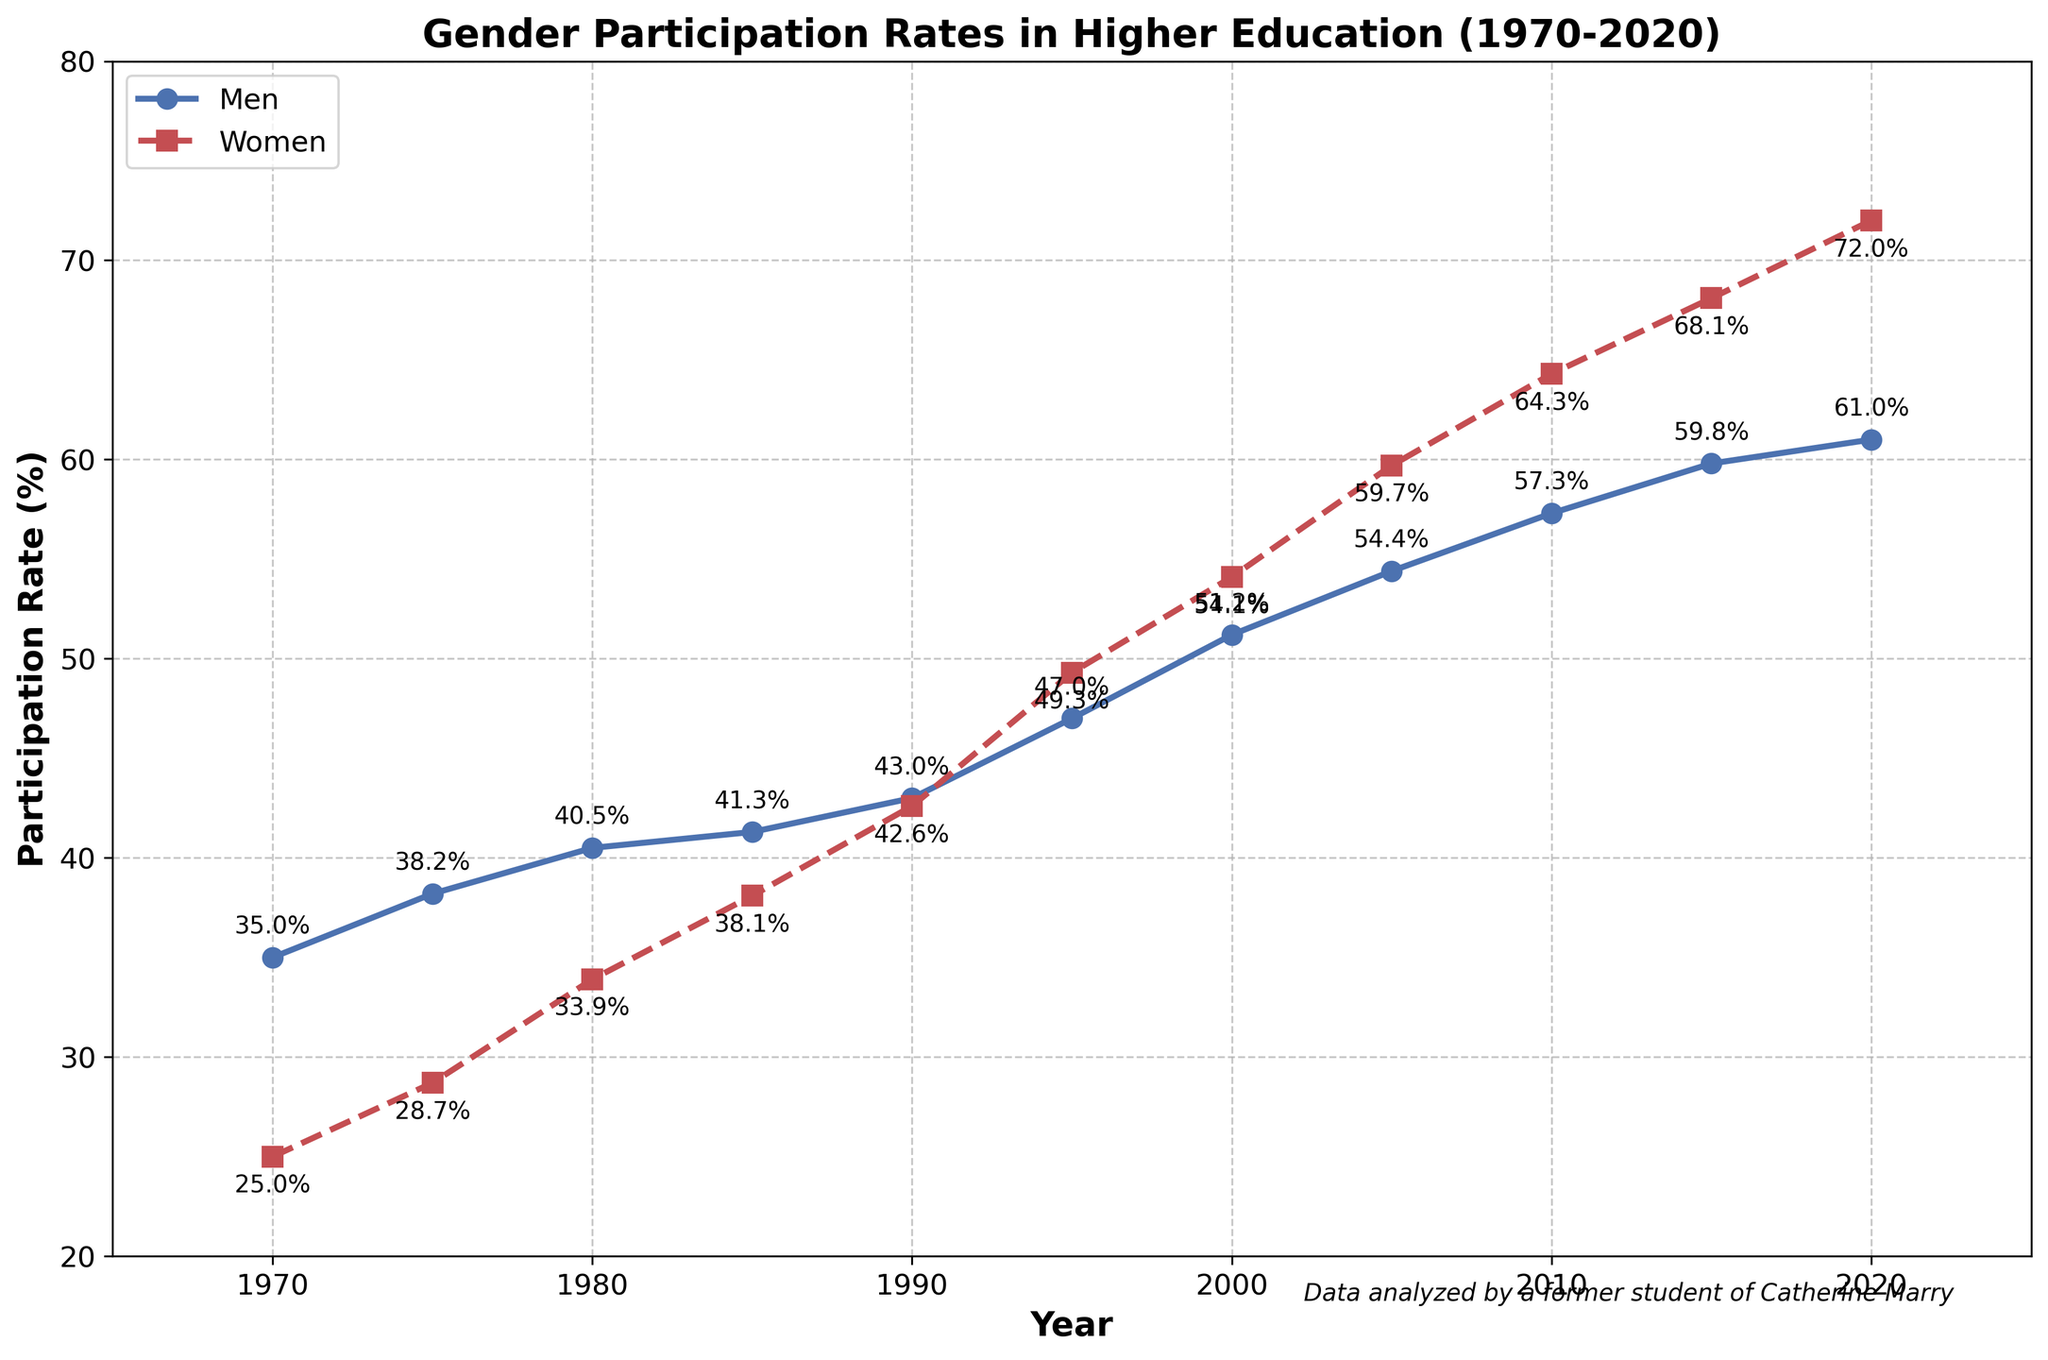When does the participation rate of women surpass that of men for the first time? By examining the plot, we observe that the women's participation rate exceeds the men's participation rate between the years 1990 and 1995. Specifically, in 1995, the women's rate is higher.
Answer: 1995 At which year do men and women have the lowest and highest participation rates respectively? By looking at the beginning of each line, the lowest participation rate for men is in 1970 at 35.0%. For women, it is also in 1970 at 25.0%. The highest rate for men is in 2020 at 61.0%. The highest rate for women is in 2020 at 72.0%.
Answer: 1970 for the lowest, 2020 for the highest What is the difference in men's participation rates between 1980 and 1990? Observing the chart, in 1980, the men's rate is 40.5%, and in 1990 it is 43.0%. Subtracting these: 43.0% - 40.5% = 2.5%.
Answer: 2.5% On average, which gender has a higher participation rate over the 50 years? By closely examining the chart, we can estimate that the women's line generally ascends higher after 1995. Averaging the values from the data into sums, and calculating their means shows women have higher rates post-1995. Thus, the average women's rate surpasses men's.
Answer: Women Which year shows the highest year-on-year increase for women's participation rates? Checking the year-on-year changes, the maximum rise in women's rate occurs between 1990 to 1995, where it moves from 42.6% to 49.3%. Calculating the difference: 49.3% - 42.6% = 6.7%, which is larger compared to other intervals.
Answer: Between 1990 and 1995 In the plotted period, in which year is the gender participation gap the smallest? The gender participation gap can be evaluated by looking at the vertical distance between both lines. The smallest gap appears around 1990, where both men's and women's rates are approximately equal, 43% and 42.6% respectively.
Answer: 1990 By how much does the women's participation rate increase from 1970 to 2020? Reading from the chart, women's participation rises from 25.0% in 1970 to 72.0% in 2020. The increase is computed as 72.0% - 25.0% = 47.0%.
Answer: 47.0% Which year has the highest participation rate difference between men and women? The largest difference can be evaluated by identifying the widest vertical distance between lines. Between 1970 and 1980, the gap is the widest around 1970, but detailed comparison shows the maximum difference is in 2020 with rates being 61.0% for men and 72.0% for women, the difference - 11.0%.
Answer: 2020 